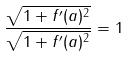Convert formula to latex. <formula><loc_0><loc_0><loc_500><loc_500>\frac { \sqrt { 1 + f ^ { \prime } ( a ) ^ { 2 } } } { \sqrt { 1 + f ^ { \prime } ( a ) ^ { 2 } } } = 1</formula> 